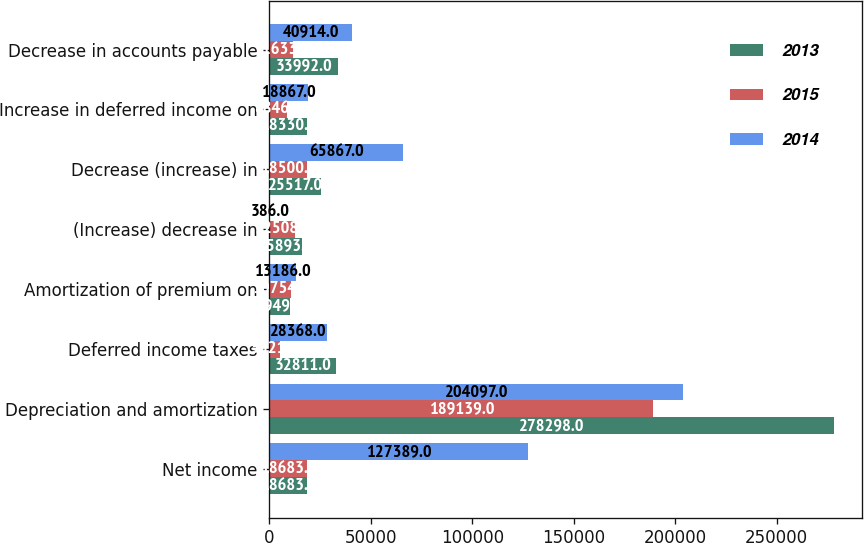Convert chart. <chart><loc_0><loc_0><loc_500><loc_500><stacked_bar_chart><ecel><fcel>Net income<fcel>Depreciation and amortization<fcel>Deferred income taxes<fcel>Amortization of premium on<fcel>(Increase) decrease in<fcel>Decrease (increase) in<fcel>Increase in deferred income on<fcel>Decrease in accounts payable<nl><fcel>2013<fcel>18683.5<fcel>278298<fcel>32811<fcel>9949<fcel>15893<fcel>25517<fcel>18330<fcel>33992<nl><fcel>2015<fcel>18683.5<fcel>189139<fcel>5321<fcel>10754<fcel>12508<fcel>18500<fcel>8846<fcel>11633<nl><fcel>2014<fcel>127389<fcel>204097<fcel>28368<fcel>13186<fcel>386<fcel>65867<fcel>18867<fcel>40914<nl></chart> 